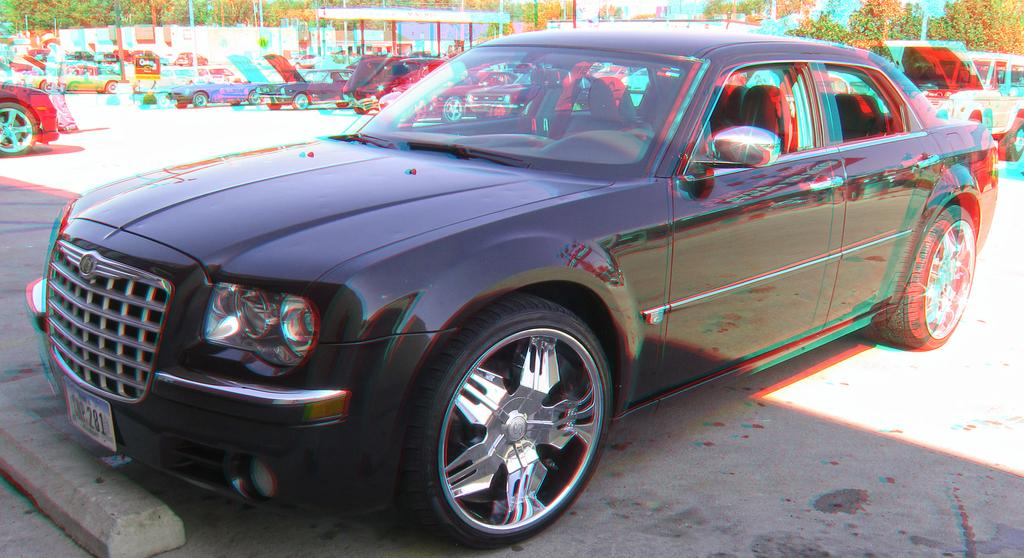What color is the car in the image? The car in the image is black. Where is the car located in the image? The car is parked on the road. What type of vegetation can be seen in the image? There are many trees in the image. What structures are present in the image? There are poles and a wall in the image. What type of zipper can be seen on the car in the image? There is no zipper present on the car in the image. What type of work is being done by the plough in the image? There is no plough present in the image. 